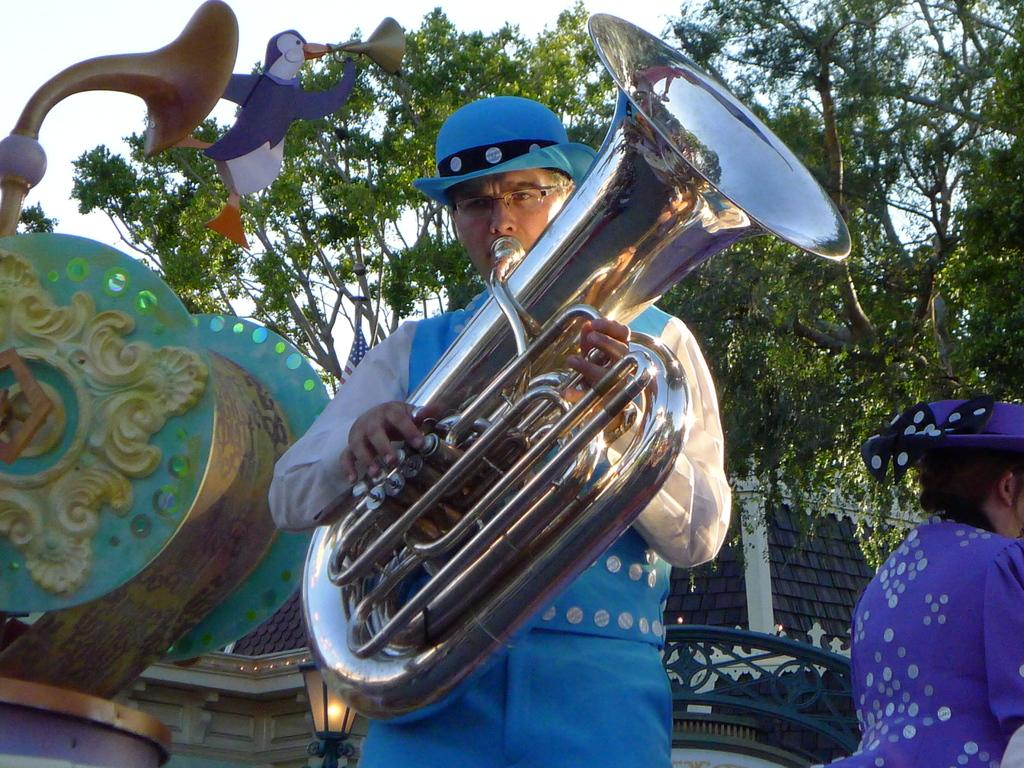What is the person in the image holding? The person is holding a tuba. Can you describe the other person in the image? There is another person in the image, but no specific details are provided. What type of structure can be seen in the image? There is a house in the image. What type of natural environment is visible in the image? There are trees in the image. What is visible in the background of the image? The sky is visible in the background of the image. What type of insect can be seen crawling on the sidewalk in the image? There is no sidewalk or insect present in the image. What type of education is the person holding the tuba pursuing in the image? There is no information about the person's education in the image. 